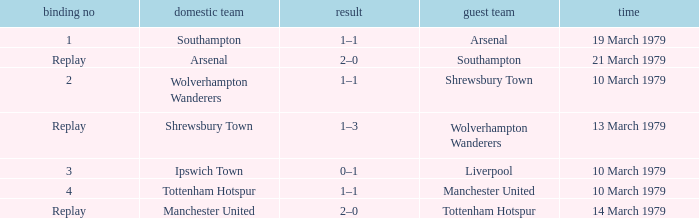What was the score of the tie that had Tottenham Hotspur as the home team? 1–1. Parse the table in full. {'header': ['binding no', 'domestic team', 'result', 'guest team', 'time'], 'rows': [['1', 'Southampton', '1–1', 'Arsenal', '19 March 1979'], ['Replay', 'Arsenal', '2–0', 'Southampton', '21 March 1979'], ['2', 'Wolverhampton Wanderers', '1–1', 'Shrewsbury Town', '10 March 1979'], ['Replay', 'Shrewsbury Town', '1–3', 'Wolverhampton Wanderers', '13 March 1979'], ['3', 'Ipswich Town', '0–1', 'Liverpool', '10 March 1979'], ['4', 'Tottenham Hotspur', '1–1', 'Manchester United', '10 March 1979'], ['Replay', 'Manchester United', '2–0', 'Tottenham Hotspur', '14 March 1979']]} 